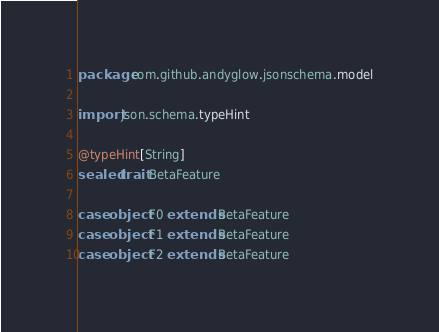Convert code to text. <code><loc_0><loc_0><loc_500><loc_500><_Scala_>package com.github.andyglow.jsonschema.model

import json.schema.typeHint

@typeHint[String]
sealed trait BetaFeature

case object F0 extends BetaFeature
case object F1 extends BetaFeature
case object F2 extends BetaFeature
</code> 